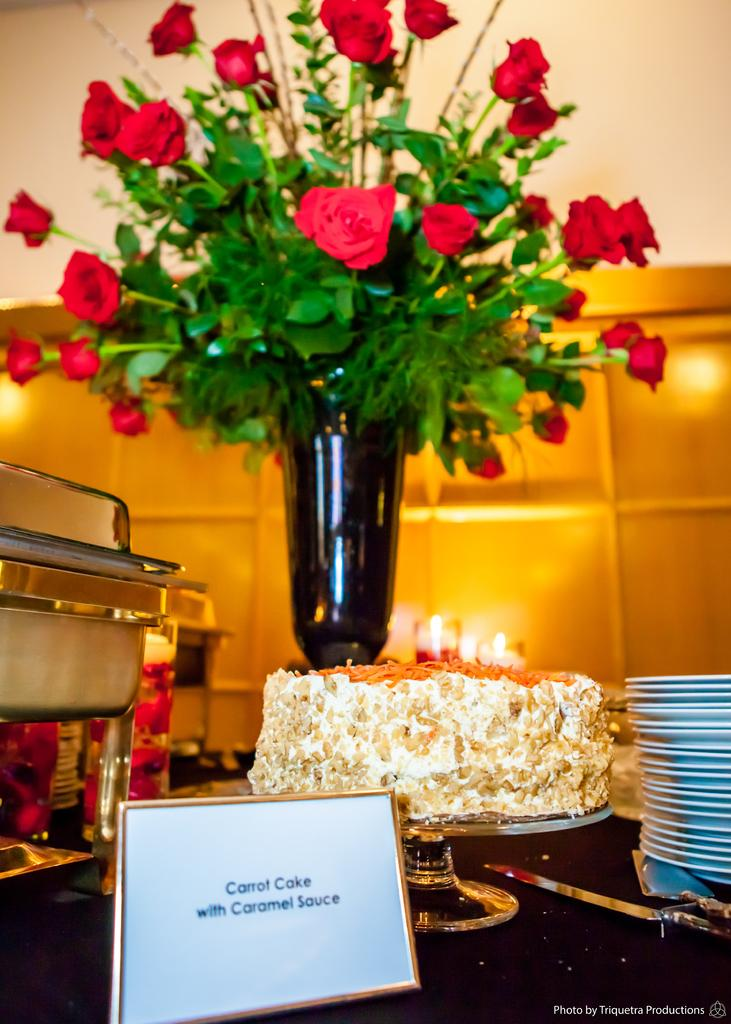What objects can be seen in the foreground of the picture? There are plates, a name plate, a cake, flowers, a flower vase, a bowl, glasses, and a knife in the foreground of the picture. What type of objects are present on the table in the foreground of the picture? Various objects, including plates, a name plate, a cake, flowers, a flower vase, a bowl, glasses, and a knife, are present on the table in the foreground of the picture. How is the background of the image depicted? The background of the image is blurred. What type of juice is being served in the glasses in the image? There is no juice present in the glasses in the image; they are empty. How many squirrels can be seen playing with the flowers in the image? There are no squirrels present in the image; it only features objects on a table in the foreground and a blurred background. 